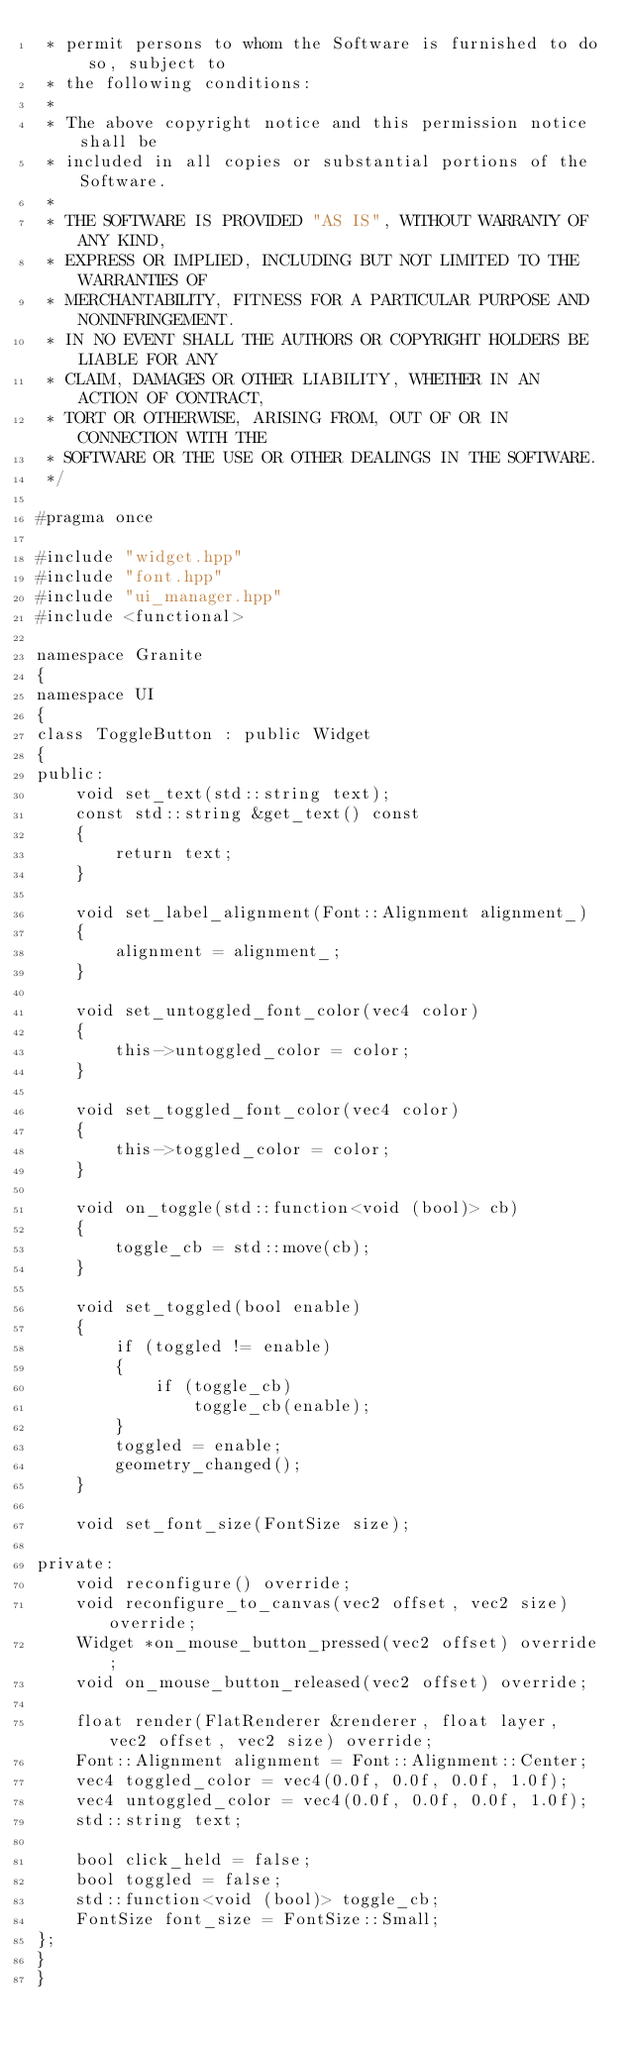<code> <loc_0><loc_0><loc_500><loc_500><_C++_> * permit persons to whom the Software is furnished to do so, subject to
 * the following conditions:
 *
 * The above copyright notice and this permission notice shall be
 * included in all copies or substantial portions of the Software.
 *
 * THE SOFTWARE IS PROVIDED "AS IS", WITHOUT WARRANTY OF ANY KIND,
 * EXPRESS OR IMPLIED, INCLUDING BUT NOT LIMITED TO THE WARRANTIES OF
 * MERCHANTABILITY, FITNESS FOR A PARTICULAR PURPOSE AND NONINFRINGEMENT.
 * IN NO EVENT SHALL THE AUTHORS OR COPYRIGHT HOLDERS BE LIABLE FOR ANY
 * CLAIM, DAMAGES OR OTHER LIABILITY, WHETHER IN AN ACTION OF CONTRACT,
 * TORT OR OTHERWISE, ARISING FROM, OUT OF OR IN CONNECTION WITH THE
 * SOFTWARE OR THE USE OR OTHER DEALINGS IN THE SOFTWARE.
 */

#pragma once

#include "widget.hpp"
#include "font.hpp"
#include "ui_manager.hpp"
#include <functional>

namespace Granite
{
namespace UI
{
class ToggleButton : public Widget
{
public:
	void set_text(std::string text);
	const std::string &get_text() const
	{
		return text;
	}

	void set_label_alignment(Font::Alignment alignment_)
	{
		alignment = alignment_;
	}

	void set_untoggled_font_color(vec4 color)
	{
		this->untoggled_color = color;
	}

	void set_toggled_font_color(vec4 color)
	{
		this->toggled_color = color;
	}

	void on_toggle(std::function<void (bool)> cb)
	{
		toggle_cb = std::move(cb);
	}

	void set_toggled(bool enable)
	{
		if (toggled != enable)
		{
			if (toggle_cb)
				toggle_cb(enable);
		}
		toggled = enable;
		geometry_changed();
	}

	void set_font_size(FontSize size);

private:
	void reconfigure() override;
	void reconfigure_to_canvas(vec2 offset, vec2 size) override;
	Widget *on_mouse_button_pressed(vec2 offset) override;
	void on_mouse_button_released(vec2 offset) override;

	float render(FlatRenderer &renderer, float layer, vec2 offset, vec2 size) override;
	Font::Alignment alignment = Font::Alignment::Center;
	vec4 toggled_color = vec4(0.0f, 0.0f, 0.0f, 1.0f);
	vec4 untoggled_color = vec4(0.0f, 0.0f, 0.0f, 1.0f);
	std::string text;

	bool click_held = false;
	bool toggled = false;
	std::function<void (bool)> toggle_cb;
	FontSize font_size = FontSize::Small;
};
}
}
</code> 